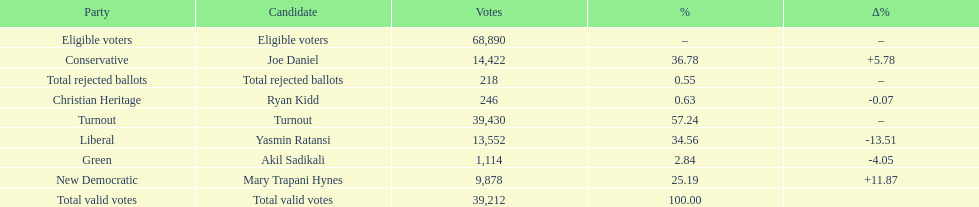Which candidate had the most votes? Joe Daniel. 